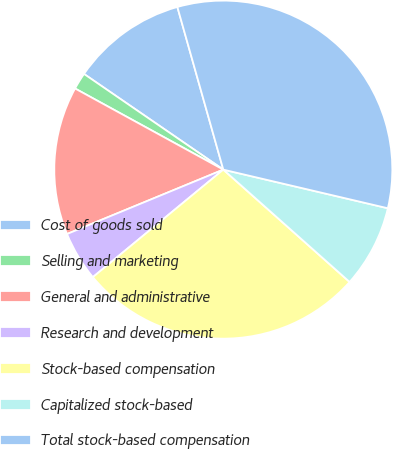Convert chart to OTSL. <chart><loc_0><loc_0><loc_500><loc_500><pie_chart><fcel>Cost of goods sold<fcel>Selling and marketing<fcel>General and administrative<fcel>Research and development<fcel>Stock-based compensation<fcel>Capitalized stock-based<fcel>Total stock-based compensation<nl><fcel>11.04%<fcel>1.61%<fcel>14.19%<fcel>4.75%<fcel>27.46%<fcel>7.9%<fcel>33.05%<nl></chart> 